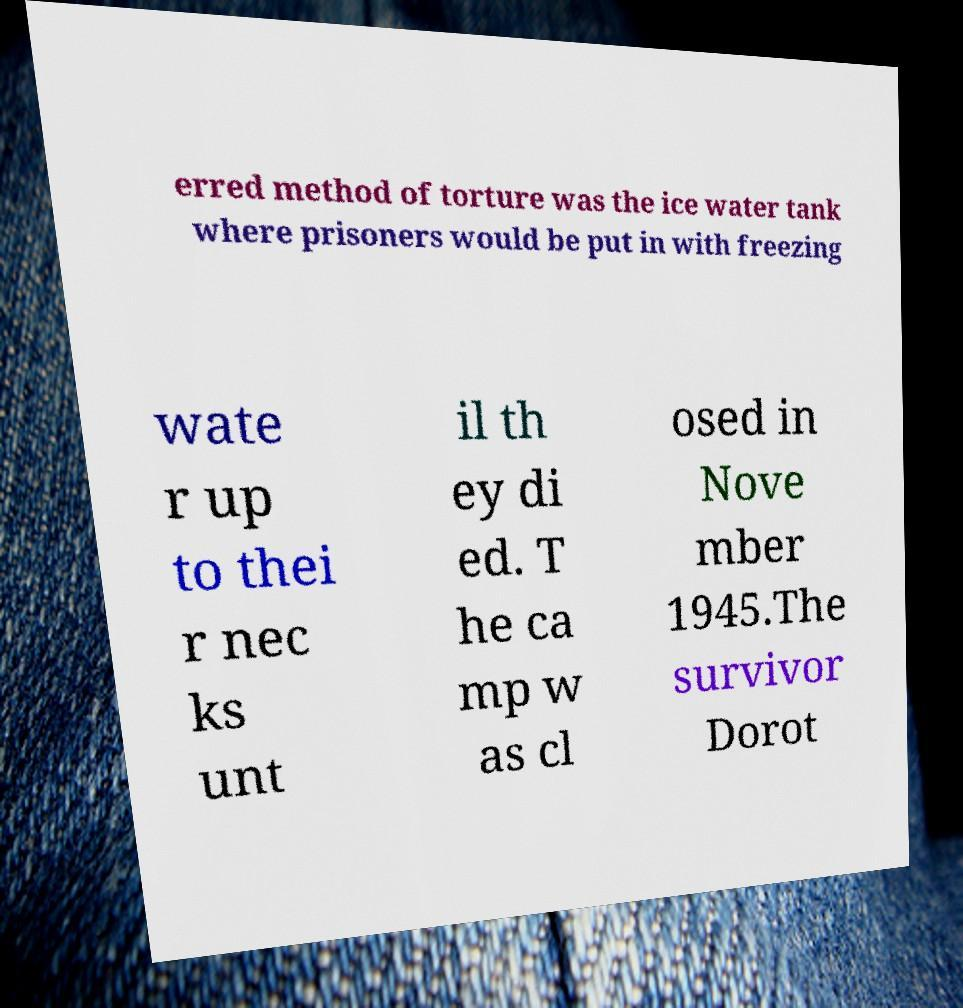Could you assist in decoding the text presented in this image and type it out clearly? erred method of torture was the ice water tank where prisoners would be put in with freezing wate r up to thei r nec ks unt il th ey di ed. T he ca mp w as cl osed in Nove mber 1945.The survivor Dorot 